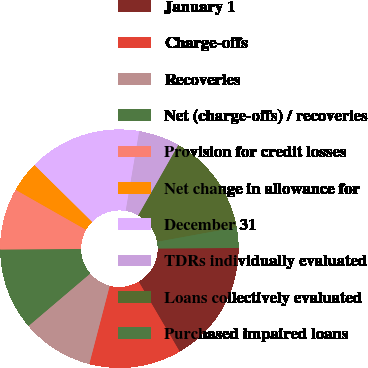Convert chart to OTSL. <chart><loc_0><loc_0><loc_500><loc_500><pie_chart><fcel>January 1<fcel>Charge-offs<fcel>Recoveries<fcel>Net (charge-offs) / recoveries<fcel>Provision for credit losses<fcel>Net change in allowance for<fcel>December 31<fcel>TDRs individually evaluated<fcel>Loans collectively evaluated<fcel>Purchased impaired loans<nl><fcel>16.66%<fcel>12.5%<fcel>9.72%<fcel>11.11%<fcel>8.33%<fcel>4.17%<fcel>15.27%<fcel>5.56%<fcel>13.89%<fcel>2.78%<nl></chart> 